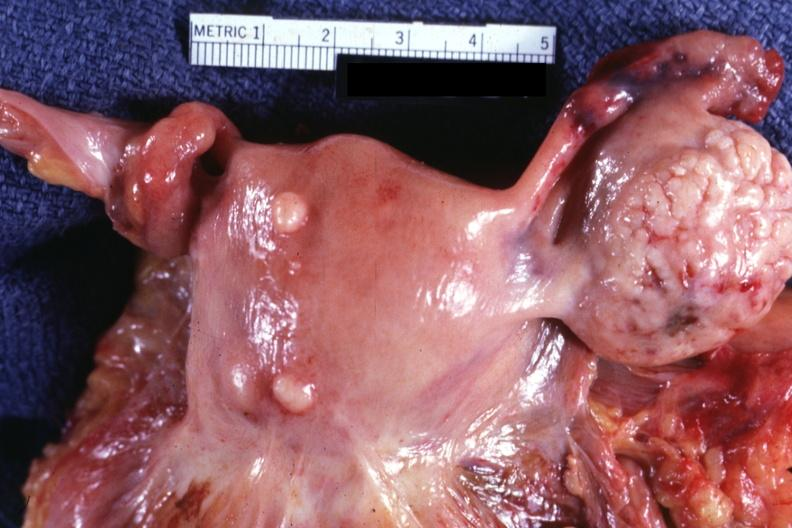what is present?
Answer the question using a single word or phrase. Leiomyomas 